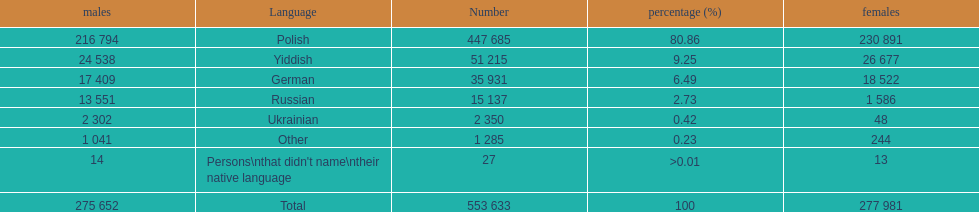How many male and female german speakers are there? 35931. 